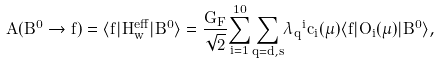<formula> <loc_0><loc_0><loc_500><loc_500>A ( B ^ { 0 } \rightarrow f ) = \langle f | H _ { w } ^ { e f f } | B ^ { 0 } \rangle = { \frac { G _ { F } } { \sqrt { 2 } } } { \sum _ { i = 1 } ^ { 1 0 } } { \sum _ { q = d , s } } { { \lambda } _ { q } } ^ { i } { c _ { i } ( { \mu } ) } { \langle f | O _ { i } ( { \mu } ) | B ^ { 0 } \rangle } ,</formula> 